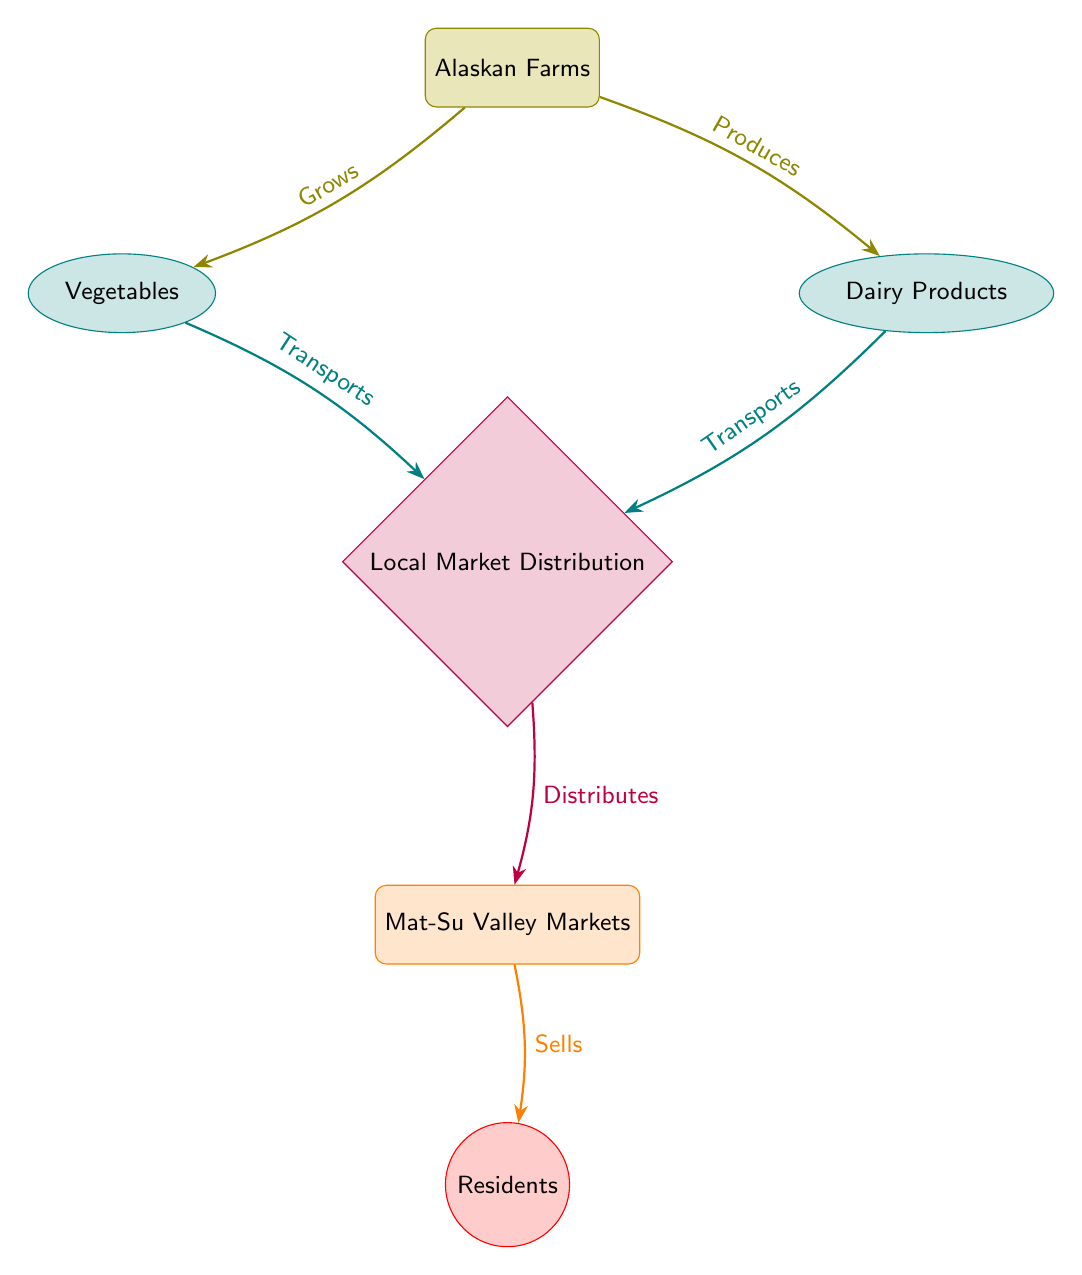What is the starting point of the food chain? The food chain begins with "Alaskan Farms," which is clearly labeled as the source node in the diagram.
Answer: Alaskan Farms How many types of products are mentioned in the diagram? There are two types of products: "Vegetables" and "Dairy Products," which are both depicted as produce nodes connected to the farms.
Answer: 2 What is the relationship between vegetables and local markets? "Vegetables" are transported to "Local Market Distribution," as indicated by the edge labeled "Transports" connecting these nodes.
Answer: Transports Which node represents the end consumers in the food chain? The end consumers in the food chain are represented by the "Residents" node, which is at the bottom of the flow.
Answer: Residents What kind of flow does the arrow between "Distribution" and "Markets" represent? The arrow indicates the flow of distribution from the "Distribution" node to the "Markets" node, labeled as "Distributes."
Answer: Distributes How many total edges are there in the diagram? By counting the connections between nodes, there are five edges: Farms to Vegetables, Farms to Dairy, Vegetables to Distribution, Dairy to Distribution, and Distribution to Markets.
Answer: 5 What role does the "Local Market Distribution" play in the food chain? The role of "Local Market Distribution" is to transport both vegetables and dairy products to local markets, consolidating the process before reaching residents.
Answer: Transport What color is used to represent the farms in the diagram? The farms are represented using the color olive, as indicated by the diagram color coding for the source node.
Answer: Olive What occurs after "Markets" in the flow of the food chain? After "Markets," the food chain flows to "Residents," indicating that the markets sell products directly to the consumers.
Answer: Residents 